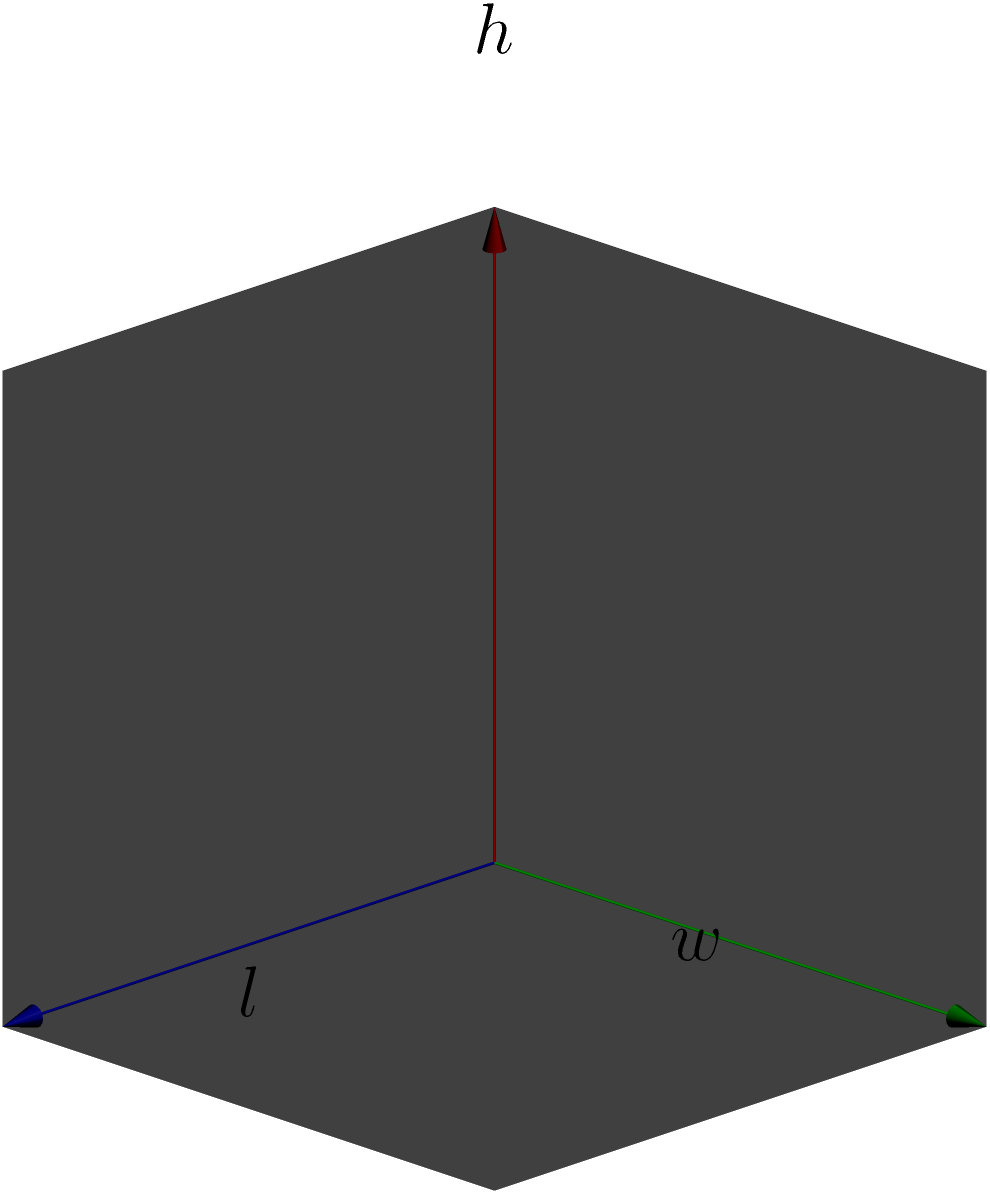You're designing a new cuboidal display case for your artisan pastries. The case has a length of 120 cm, a width of 80 cm, and a height of 60 cm. To ensure proper insurance coverage, you need to calculate the total surface area of the display case. What is the surface area in square meters? To calculate the surface area of a cuboid (rectangular prism), we need to:

1. Calculate the area of each face
2. Sum up the areas of all faces

Let's break it down step-by-step:

1. Dimensions of the display case:
   Length $(l) = 120$ cm
   Width $(w) = 80$ cm
   Height $(h) = 60$ cm

2. Calculate the areas:
   - Top and bottom faces: $l \times w = 120 \text{ cm} \times 80 \text{ cm} = 9600 \text{ cm}^2$ (2 faces)
   - Front and back faces: $l \times h = 120 \text{ cm} \times 60 \text{ cm} = 7200 \text{ cm}^2$ (2 faces)
   - Side faces: $w \times h = 80 \text{ cm} \times 60 \text{ cm} = 4800 \text{ cm}^2$ (2 faces)

3. Sum up all the areas:
   Total surface area $= 2(l\times w + l\times h + w\times h)$
   $= 2(9600 + 7200 + 4800) \text{ cm}^2$
   $= 2(21600) \text{ cm}^2$
   $= 43200 \text{ cm}^2$

4. Convert to square meters:
   $43200 \text{ cm}^2 = 4.32 \text{ m}^2$

Therefore, the total surface area of the display case is 4.32 square meters.
Answer: $4.32 \text{ m}^2$ 